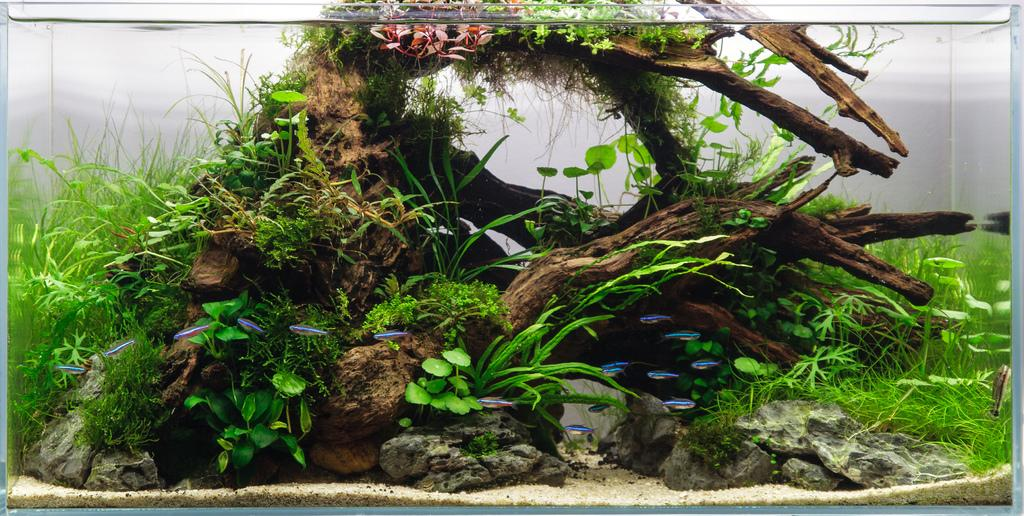What is the main subject of the picture? The main subject of the picture is an aquarium. What is inside the aquarium? The aquarium contains water, plants, grass, leaves, and a wooden structure. Can you describe the plants in the aquarium? The plants in the aquarium are submerged in water. What type of structure is present in the aquarium? There is a wooden structure in the aquarium. What type of cream is being used to paint the regret in the image? There is no cream or painting activity present in the image; it features an aquarium with water, plants, grass, leaves, and a wooden structure. 